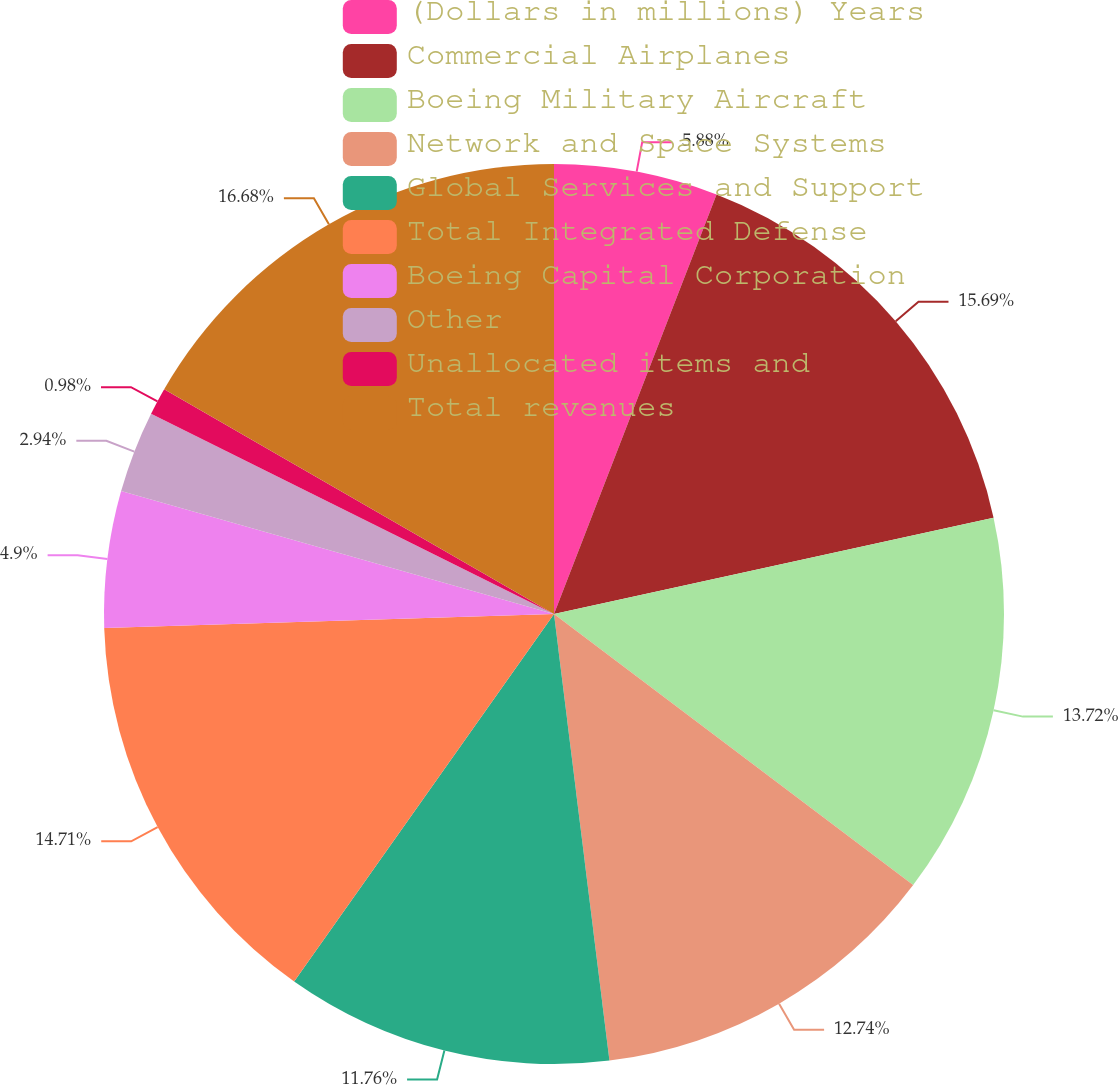Convert chart. <chart><loc_0><loc_0><loc_500><loc_500><pie_chart><fcel>(Dollars in millions) Years<fcel>Commercial Airplanes<fcel>Boeing Military Aircraft<fcel>Network and Space Systems<fcel>Global Services and Support<fcel>Total Integrated Defense<fcel>Boeing Capital Corporation<fcel>Other<fcel>Unallocated items and<fcel>Total revenues<nl><fcel>5.88%<fcel>15.68%<fcel>13.72%<fcel>12.74%<fcel>11.76%<fcel>14.7%<fcel>4.9%<fcel>2.94%<fcel>0.98%<fcel>16.67%<nl></chart> 